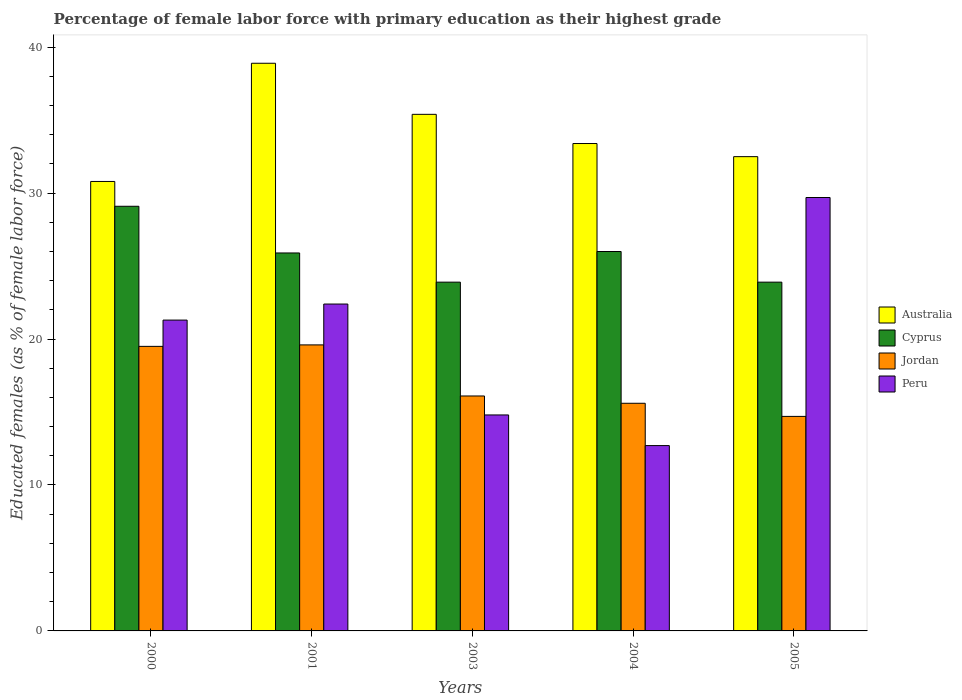How many different coloured bars are there?
Provide a short and direct response. 4. Are the number of bars per tick equal to the number of legend labels?
Offer a terse response. Yes. Are the number of bars on each tick of the X-axis equal?
Provide a succinct answer. Yes. How many bars are there on the 3rd tick from the left?
Offer a very short reply. 4. How many bars are there on the 5th tick from the right?
Offer a very short reply. 4. What is the percentage of female labor force with primary education in Australia in 2003?
Offer a very short reply. 35.4. Across all years, what is the maximum percentage of female labor force with primary education in Cyprus?
Give a very brief answer. 29.1. Across all years, what is the minimum percentage of female labor force with primary education in Peru?
Provide a short and direct response. 12.7. What is the total percentage of female labor force with primary education in Cyprus in the graph?
Ensure brevity in your answer.  128.8. What is the difference between the percentage of female labor force with primary education in Jordan in 2000 and that in 2004?
Your response must be concise. 3.9. What is the difference between the percentage of female labor force with primary education in Australia in 2003 and the percentage of female labor force with primary education in Cyprus in 2004?
Your answer should be compact. 9.4. What is the average percentage of female labor force with primary education in Peru per year?
Provide a succinct answer. 20.18. In the year 2005, what is the difference between the percentage of female labor force with primary education in Cyprus and percentage of female labor force with primary education in Jordan?
Give a very brief answer. 9.2. Is the percentage of female labor force with primary education in Australia in 2001 less than that in 2003?
Keep it short and to the point. No. What is the difference between the highest and the second highest percentage of female labor force with primary education in Peru?
Your answer should be compact. 7.3. What is the difference between the highest and the lowest percentage of female labor force with primary education in Australia?
Your answer should be compact. 8.1. In how many years, is the percentage of female labor force with primary education in Jordan greater than the average percentage of female labor force with primary education in Jordan taken over all years?
Give a very brief answer. 2. Is the sum of the percentage of female labor force with primary education in Jordan in 2000 and 2004 greater than the maximum percentage of female labor force with primary education in Cyprus across all years?
Offer a terse response. Yes. What does the 2nd bar from the left in 2000 represents?
Offer a terse response. Cyprus. What does the 4th bar from the right in 2003 represents?
Offer a very short reply. Australia. Is it the case that in every year, the sum of the percentage of female labor force with primary education in Australia and percentage of female labor force with primary education in Peru is greater than the percentage of female labor force with primary education in Jordan?
Your response must be concise. Yes. How many bars are there?
Give a very brief answer. 20. How many years are there in the graph?
Your answer should be very brief. 5. Does the graph contain any zero values?
Offer a terse response. No. Does the graph contain grids?
Your answer should be very brief. No. Where does the legend appear in the graph?
Your response must be concise. Center right. What is the title of the graph?
Your answer should be compact. Percentage of female labor force with primary education as their highest grade. What is the label or title of the X-axis?
Offer a very short reply. Years. What is the label or title of the Y-axis?
Your answer should be very brief. Educated females (as % of female labor force). What is the Educated females (as % of female labor force) of Australia in 2000?
Ensure brevity in your answer.  30.8. What is the Educated females (as % of female labor force) in Cyprus in 2000?
Your response must be concise. 29.1. What is the Educated females (as % of female labor force) in Jordan in 2000?
Offer a terse response. 19.5. What is the Educated females (as % of female labor force) in Peru in 2000?
Offer a very short reply. 21.3. What is the Educated females (as % of female labor force) of Australia in 2001?
Your response must be concise. 38.9. What is the Educated females (as % of female labor force) in Cyprus in 2001?
Ensure brevity in your answer.  25.9. What is the Educated females (as % of female labor force) of Jordan in 2001?
Your answer should be compact. 19.6. What is the Educated females (as % of female labor force) in Peru in 2001?
Offer a terse response. 22.4. What is the Educated females (as % of female labor force) of Australia in 2003?
Provide a short and direct response. 35.4. What is the Educated females (as % of female labor force) in Cyprus in 2003?
Ensure brevity in your answer.  23.9. What is the Educated females (as % of female labor force) of Jordan in 2003?
Give a very brief answer. 16.1. What is the Educated females (as % of female labor force) in Peru in 2003?
Ensure brevity in your answer.  14.8. What is the Educated females (as % of female labor force) of Australia in 2004?
Offer a terse response. 33.4. What is the Educated females (as % of female labor force) of Jordan in 2004?
Ensure brevity in your answer.  15.6. What is the Educated females (as % of female labor force) in Peru in 2004?
Offer a terse response. 12.7. What is the Educated females (as % of female labor force) of Australia in 2005?
Provide a succinct answer. 32.5. What is the Educated females (as % of female labor force) in Cyprus in 2005?
Ensure brevity in your answer.  23.9. What is the Educated females (as % of female labor force) of Jordan in 2005?
Keep it short and to the point. 14.7. What is the Educated females (as % of female labor force) in Peru in 2005?
Ensure brevity in your answer.  29.7. Across all years, what is the maximum Educated females (as % of female labor force) of Australia?
Your answer should be compact. 38.9. Across all years, what is the maximum Educated females (as % of female labor force) in Cyprus?
Provide a short and direct response. 29.1. Across all years, what is the maximum Educated females (as % of female labor force) in Jordan?
Your answer should be compact. 19.6. Across all years, what is the maximum Educated females (as % of female labor force) of Peru?
Keep it short and to the point. 29.7. Across all years, what is the minimum Educated females (as % of female labor force) of Australia?
Give a very brief answer. 30.8. Across all years, what is the minimum Educated females (as % of female labor force) in Cyprus?
Keep it short and to the point. 23.9. Across all years, what is the minimum Educated females (as % of female labor force) in Jordan?
Keep it short and to the point. 14.7. Across all years, what is the minimum Educated females (as % of female labor force) in Peru?
Keep it short and to the point. 12.7. What is the total Educated females (as % of female labor force) in Australia in the graph?
Offer a terse response. 171. What is the total Educated females (as % of female labor force) in Cyprus in the graph?
Make the answer very short. 128.8. What is the total Educated females (as % of female labor force) of Jordan in the graph?
Provide a short and direct response. 85.5. What is the total Educated females (as % of female labor force) in Peru in the graph?
Make the answer very short. 100.9. What is the difference between the Educated females (as % of female labor force) of Australia in 2000 and that in 2003?
Give a very brief answer. -4.6. What is the difference between the Educated females (as % of female labor force) in Cyprus in 2000 and that in 2003?
Keep it short and to the point. 5.2. What is the difference between the Educated females (as % of female labor force) in Jordan in 2000 and that in 2003?
Your answer should be very brief. 3.4. What is the difference between the Educated females (as % of female labor force) of Peru in 2000 and that in 2003?
Your response must be concise. 6.5. What is the difference between the Educated females (as % of female labor force) in Australia in 2000 and that in 2004?
Your response must be concise. -2.6. What is the difference between the Educated females (as % of female labor force) in Jordan in 2000 and that in 2004?
Offer a terse response. 3.9. What is the difference between the Educated females (as % of female labor force) in Cyprus in 2000 and that in 2005?
Your answer should be compact. 5.2. What is the difference between the Educated females (as % of female labor force) of Peru in 2000 and that in 2005?
Keep it short and to the point. -8.4. What is the difference between the Educated females (as % of female labor force) of Australia in 2001 and that in 2003?
Ensure brevity in your answer.  3.5. What is the difference between the Educated females (as % of female labor force) of Australia in 2001 and that in 2004?
Provide a succinct answer. 5.5. What is the difference between the Educated females (as % of female labor force) in Jordan in 2001 and that in 2004?
Offer a very short reply. 4. What is the difference between the Educated females (as % of female labor force) of Australia in 2001 and that in 2005?
Your answer should be very brief. 6.4. What is the difference between the Educated females (as % of female labor force) in Cyprus in 2001 and that in 2005?
Offer a terse response. 2. What is the difference between the Educated females (as % of female labor force) in Jordan in 2001 and that in 2005?
Your answer should be very brief. 4.9. What is the difference between the Educated females (as % of female labor force) of Cyprus in 2003 and that in 2004?
Provide a short and direct response. -2.1. What is the difference between the Educated females (as % of female labor force) in Australia in 2003 and that in 2005?
Provide a short and direct response. 2.9. What is the difference between the Educated females (as % of female labor force) of Cyprus in 2003 and that in 2005?
Your answer should be compact. 0. What is the difference between the Educated females (as % of female labor force) in Jordan in 2003 and that in 2005?
Provide a succinct answer. 1.4. What is the difference between the Educated females (as % of female labor force) in Peru in 2003 and that in 2005?
Your answer should be very brief. -14.9. What is the difference between the Educated females (as % of female labor force) in Australia in 2004 and that in 2005?
Offer a terse response. 0.9. What is the difference between the Educated females (as % of female labor force) in Cyprus in 2004 and that in 2005?
Provide a succinct answer. 2.1. What is the difference between the Educated females (as % of female labor force) in Australia in 2000 and the Educated females (as % of female labor force) in Cyprus in 2001?
Provide a short and direct response. 4.9. What is the difference between the Educated females (as % of female labor force) of Australia in 2000 and the Educated females (as % of female labor force) of Peru in 2001?
Give a very brief answer. 8.4. What is the difference between the Educated females (as % of female labor force) of Cyprus in 2000 and the Educated females (as % of female labor force) of Jordan in 2001?
Provide a short and direct response. 9.5. What is the difference between the Educated females (as % of female labor force) in Cyprus in 2000 and the Educated females (as % of female labor force) in Peru in 2001?
Offer a terse response. 6.7. What is the difference between the Educated females (as % of female labor force) in Australia in 2000 and the Educated females (as % of female labor force) in Jordan in 2003?
Provide a succinct answer. 14.7. What is the difference between the Educated females (as % of female labor force) of Cyprus in 2000 and the Educated females (as % of female labor force) of Jordan in 2003?
Offer a very short reply. 13. What is the difference between the Educated females (as % of female labor force) of Cyprus in 2000 and the Educated females (as % of female labor force) of Peru in 2003?
Make the answer very short. 14.3. What is the difference between the Educated females (as % of female labor force) of Jordan in 2000 and the Educated females (as % of female labor force) of Peru in 2003?
Provide a succinct answer. 4.7. What is the difference between the Educated females (as % of female labor force) of Australia in 2000 and the Educated females (as % of female labor force) of Jordan in 2004?
Ensure brevity in your answer.  15.2. What is the difference between the Educated females (as % of female labor force) in Cyprus in 2000 and the Educated females (as % of female labor force) in Jordan in 2004?
Offer a very short reply. 13.5. What is the difference between the Educated females (as % of female labor force) of Cyprus in 2000 and the Educated females (as % of female labor force) of Peru in 2004?
Offer a very short reply. 16.4. What is the difference between the Educated females (as % of female labor force) of Jordan in 2000 and the Educated females (as % of female labor force) of Peru in 2004?
Offer a very short reply. 6.8. What is the difference between the Educated females (as % of female labor force) in Australia in 2000 and the Educated females (as % of female labor force) in Peru in 2005?
Provide a succinct answer. 1.1. What is the difference between the Educated females (as % of female labor force) of Cyprus in 2000 and the Educated females (as % of female labor force) of Jordan in 2005?
Offer a very short reply. 14.4. What is the difference between the Educated females (as % of female labor force) of Cyprus in 2000 and the Educated females (as % of female labor force) of Peru in 2005?
Provide a succinct answer. -0.6. What is the difference between the Educated females (as % of female labor force) in Australia in 2001 and the Educated females (as % of female labor force) in Cyprus in 2003?
Your response must be concise. 15. What is the difference between the Educated females (as % of female labor force) of Australia in 2001 and the Educated females (as % of female labor force) of Jordan in 2003?
Keep it short and to the point. 22.8. What is the difference between the Educated females (as % of female labor force) of Australia in 2001 and the Educated females (as % of female labor force) of Peru in 2003?
Your answer should be very brief. 24.1. What is the difference between the Educated females (as % of female labor force) of Cyprus in 2001 and the Educated females (as % of female labor force) of Jordan in 2003?
Keep it short and to the point. 9.8. What is the difference between the Educated females (as % of female labor force) of Cyprus in 2001 and the Educated females (as % of female labor force) of Peru in 2003?
Your answer should be very brief. 11.1. What is the difference between the Educated females (as % of female labor force) in Australia in 2001 and the Educated females (as % of female labor force) in Jordan in 2004?
Keep it short and to the point. 23.3. What is the difference between the Educated females (as % of female labor force) in Australia in 2001 and the Educated females (as % of female labor force) in Peru in 2004?
Your answer should be compact. 26.2. What is the difference between the Educated females (as % of female labor force) in Cyprus in 2001 and the Educated females (as % of female labor force) in Peru in 2004?
Your answer should be compact. 13.2. What is the difference between the Educated females (as % of female labor force) of Australia in 2001 and the Educated females (as % of female labor force) of Cyprus in 2005?
Offer a terse response. 15. What is the difference between the Educated females (as % of female labor force) of Australia in 2001 and the Educated females (as % of female labor force) of Jordan in 2005?
Offer a very short reply. 24.2. What is the difference between the Educated females (as % of female labor force) in Cyprus in 2001 and the Educated females (as % of female labor force) in Jordan in 2005?
Ensure brevity in your answer.  11.2. What is the difference between the Educated females (as % of female labor force) of Australia in 2003 and the Educated females (as % of female labor force) of Cyprus in 2004?
Provide a short and direct response. 9.4. What is the difference between the Educated females (as % of female labor force) of Australia in 2003 and the Educated females (as % of female labor force) of Jordan in 2004?
Ensure brevity in your answer.  19.8. What is the difference between the Educated females (as % of female labor force) of Australia in 2003 and the Educated females (as % of female labor force) of Peru in 2004?
Keep it short and to the point. 22.7. What is the difference between the Educated females (as % of female labor force) of Cyprus in 2003 and the Educated females (as % of female labor force) of Jordan in 2004?
Your response must be concise. 8.3. What is the difference between the Educated females (as % of female labor force) in Jordan in 2003 and the Educated females (as % of female labor force) in Peru in 2004?
Ensure brevity in your answer.  3.4. What is the difference between the Educated females (as % of female labor force) of Australia in 2003 and the Educated females (as % of female labor force) of Jordan in 2005?
Give a very brief answer. 20.7. What is the difference between the Educated females (as % of female labor force) of Australia in 2003 and the Educated females (as % of female labor force) of Peru in 2005?
Provide a succinct answer. 5.7. What is the difference between the Educated females (as % of female labor force) of Cyprus in 2003 and the Educated females (as % of female labor force) of Peru in 2005?
Your answer should be compact. -5.8. What is the difference between the Educated females (as % of female labor force) in Australia in 2004 and the Educated females (as % of female labor force) in Jordan in 2005?
Your answer should be compact. 18.7. What is the difference between the Educated females (as % of female labor force) in Cyprus in 2004 and the Educated females (as % of female labor force) in Jordan in 2005?
Offer a terse response. 11.3. What is the difference between the Educated females (as % of female labor force) of Jordan in 2004 and the Educated females (as % of female labor force) of Peru in 2005?
Keep it short and to the point. -14.1. What is the average Educated females (as % of female labor force) in Australia per year?
Keep it short and to the point. 34.2. What is the average Educated females (as % of female labor force) in Cyprus per year?
Ensure brevity in your answer.  25.76. What is the average Educated females (as % of female labor force) in Jordan per year?
Offer a very short reply. 17.1. What is the average Educated females (as % of female labor force) in Peru per year?
Make the answer very short. 20.18. In the year 2000, what is the difference between the Educated females (as % of female labor force) in Australia and Educated females (as % of female labor force) in Cyprus?
Your answer should be compact. 1.7. In the year 2000, what is the difference between the Educated females (as % of female labor force) in Cyprus and Educated females (as % of female labor force) in Peru?
Your response must be concise. 7.8. In the year 2000, what is the difference between the Educated females (as % of female labor force) in Jordan and Educated females (as % of female labor force) in Peru?
Ensure brevity in your answer.  -1.8. In the year 2001, what is the difference between the Educated females (as % of female labor force) in Australia and Educated females (as % of female labor force) in Jordan?
Your response must be concise. 19.3. In the year 2001, what is the difference between the Educated females (as % of female labor force) in Australia and Educated females (as % of female labor force) in Peru?
Provide a succinct answer. 16.5. In the year 2001, what is the difference between the Educated females (as % of female labor force) of Cyprus and Educated females (as % of female labor force) of Jordan?
Give a very brief answer. 6.3. In the year 2001, what is the difference between the Educated females (as % of female labor force) in Cyprus and Educated females (as % of female labor force) in Peru?
Your response must be concise. 3.5. In the year 2003, what is the difference between the Educated females (as % of female labor force) in Australia and Educated females (as % of female labor force) in Cyprus?
Offer a very short reply. 11.5. In the year 2003, what is the difference between the Educated females (as % of female labor force) of Australia and Educated females (as % of female labor force) of Jordan?
Your answer should be very brief. 19.3. In the year 2003, what is the difference between the Educated females (as % of female labor force) of Australia and Educated females (as % of female labor force) of Peru?
Ensure brevity in your answer.  20.6. In the year 2003, what is the difference between the Educated females (as % of female labor force) of Cyprus and Educated females (as % of female labor force) of Jordan?
Offer a terse response. 7.8. In the year 2004, what is the difference between the Educated females (as % of female labor force) in Australia and Educated females (as % of female labor force) in Cyprus?
Provide a succinct answer. 7.4. In the year 2004, what is the difference between the Educated females (as % of female labor force) in Australia and Educated females (as % of female labor force) in Peru?
Keep it short and to the point. 20.7. In the year 2004, what is the difference between the Educated females (as % of female labor force) in Jordan and Educated females (as % of female labor force) in Peru?
Your answer should be very brief. 2.9. In the year 2005, what is the difference between the Educated females (as % of female labor force) in Australia and Educated females (as % of female labor force) in Cyprus?
Provide a succinct answer. 8.6. In the year 2005, what is the difference between the Educated females (as % of female labor force) in Australia and Educated females (as % of female labor force) in Peru?
Provide a short and direct response. 2.8. In the year 2005, what is the difference between the Educated females (as % of female labor force) in Jordan and Educated females (as % of female labor force) in Peru?
Your response must be concise. -15. What is the ratio of the Educated females (as % of female labor force) of Australia in 2000 to that in 2001?
Ensure brevity in your answer.  0.79. What is the ratio of the Educated females (as % of female labor force) in Cyprus in 2000 to that in 2001?
Your answer should be compact. 1.12. What is the ratio of the Educated females (as % of female labor force) in Jordan in 2000 to that in 2001?
Provide a short and direct response. 0.99. What is the ratio of the Educated females (as % of female labor force) in Peru in 2000 to that in 2001?
Your answer should be very brief. 0.95. What is the ratio of the Educated females (as % of female labor force) of Australia in 2000 to that in 2003?
Offer a terse response. 0.87. What is the ratio of the Educated females (as % of female labor force) in Cyprus in 2000 to that in 2003?
Your answer should be very brief. 1.22. What is the ratio of the Educated females (as % of female labor force) in Jordan in 2000 to that in 2003?
Keep it short and to the point. 1.21. What is the ratio of the Educated females (as % of female labor force) of Peru in 2000 to that in 2003?
Your response must be concise. 1.44. What is the ratio of the Educated females (as % of female labor force) in Australia in 2000 to that in 2004?
Your answer should be very brief. 0.92. What is the ratio of the Educated females (as % of female labor force) of Cyprus in 2000 to that in 2004?
Ensure brevity in your answer.  1.12. What is the ratio of the Educated females (as % of female labor force) of Peru in 2000 to that in 2004?
Give a very brief answer. 1.68. What is the ratio of the Educated females (as % of female labor force) in Australia in 2000 to that in 2005?
Your response must be concise. 0.95. What is the ratio of the Educated females (as % of female labor force) of Cyprus in 2000 to that in 2005?
Provide a short and direct response. 1.22. What is the ratio of the Educated females (as % of female labor force) of Jordan in 2000 to that in 2005?
Provide a succinct answer. 1.33. What is the ratio of the Educated females (as % of female labor force) in Peru in 2000 to that in 2005?
Offer a very short reply. 0.72. What is the ratio of the Educated females (as % of female labor force) in Australia in 2001 to that in 2003?
Provide a succinct answer. 1.1. What is the ratio of the Educated females (as % of female labor force) of Cyprus in 2001 to that in 2003?
Provide a short and direct response. 1.08. What is the ratio of the Educated females (as % of female labor force) of Jordan in 2001 to that in 2003?
Your answer should be compact. 1.22. What is the ratio of the Educated females (as % of female labor force) in Peru in 2001 to that in 2003?
Your answer should be very brief. 1.51. What is the ratio of the Educated females (as % of female labor force) of Australia in 2001 to that in 2004?
Offer a very short reply. 1.16. What is the ratio of the Educated females (as % of female labor force) in Cyprus in 2001 to that in 2004?
Ensure brevity in your answer.  1. What is the ratio of the Educated females (as % of female labor force) of Jordan in 2001 to that in 2004?
Your answer should be compact. 1.26. What is the ratio of the Educated females (as % of female labor force) in Peru in 2001 to that in 2004?
Your response must be concise. 1.76. What is the ratio of the Educated females (as % of female labor force) of Australia in 2001 to that in 2005?
Offer a very short reply. 1.2. What is the ratio of the Educated females (as % of female labor force) in Cyprus in 2001 to that in 2005?
Your answer should be compact. 1.08. What is the ratio of the Educated females (as % of female labor force) in Jordan in 2001 to that in 2005?
Your answer should be very brief. 1.33. What is the ratio of the Educated females (as % of female labor force) of Peru in 2001 to that in 2005?
Offer a terse response. 0.75. What is the ratio of the Educated females (as % of female labor force) of Australia in 2003 to that in 2004?
Your answer should be compact. 1.06. What is the ratio of the Educated females (as % of female labor force) in Cyprus in 2003 to that in 2004?
Offer a terse response. 0.92. What is the ratio of the Educated females (as % of female labor force) of Jordan in 2003 to that in 2004?
Provide a short and direct response. 1.03. What is the ratio of the Educated females (as % of female labor force) of Peru in 2003 to that in 2004?
Make the answer very short. 1.17. What is the ratio of the Educated females (as % of female labor force) in Australia in 2003 to that in 2005?
Offer a very short reply. 1.09. What is the ratio of the Educated females (as % of female labor force) of Cyprus in 2003 to that in 2005?
Provide a short and direct response. 1. What is the ratio of the Educated females (as % of female labor force) of Jordan in 2003 to that in 2005?
Make the answer very short. 1.1. What is the ratio of the Educated females (as % of female labor force) in Peru in 2003 to that in 2005?
Give a very brief answer. 0.5. What is the ratio of the Educated females (as % of female labor force) in Australia in 2004 to that in 2005?
Give a very brief answer. 1.03. What is the ratio of the Educated females (as % of female labor force) of Cyprus in 2004 to that in 2005?
Provide a succinct answer. 1.09. What is the ratio of the Educated females (as % of female labor force) in Jordan in 2004 to that in 2005?
Ensure brevity in your answer.  1.06. What is the ratio of the Educated females (as % of female labor force) in Peru in 2004 to that in 2005?
Offer a terse response. 0.43. What is the difference between the highest and the second highest Educated females (as % of female labor force) in Cyprus?
Provide a succinct answer. 3.1. What is the difference between the highest and the second highest Educated females (as % of female labor force) of Jordan?
Make the answer very short. 0.1. What is the difference between the highest and the second highest Educated females (as % of female labor force) of Peru?
Your response must be concise. 7.3. What is the difference between the highest and the lowest Educated females (as % of female labor force) in Australia?
Offer a terse response. 8.1. What is the difference between the highest and the lowest Educated females (as % of female labor force) of Cyprus?
Keep it short and to the point. 5.2. What is the difference between the highest and the lowest Educated females (as % of female labor force) of Peru?
Provide a succinct answer. 17. 